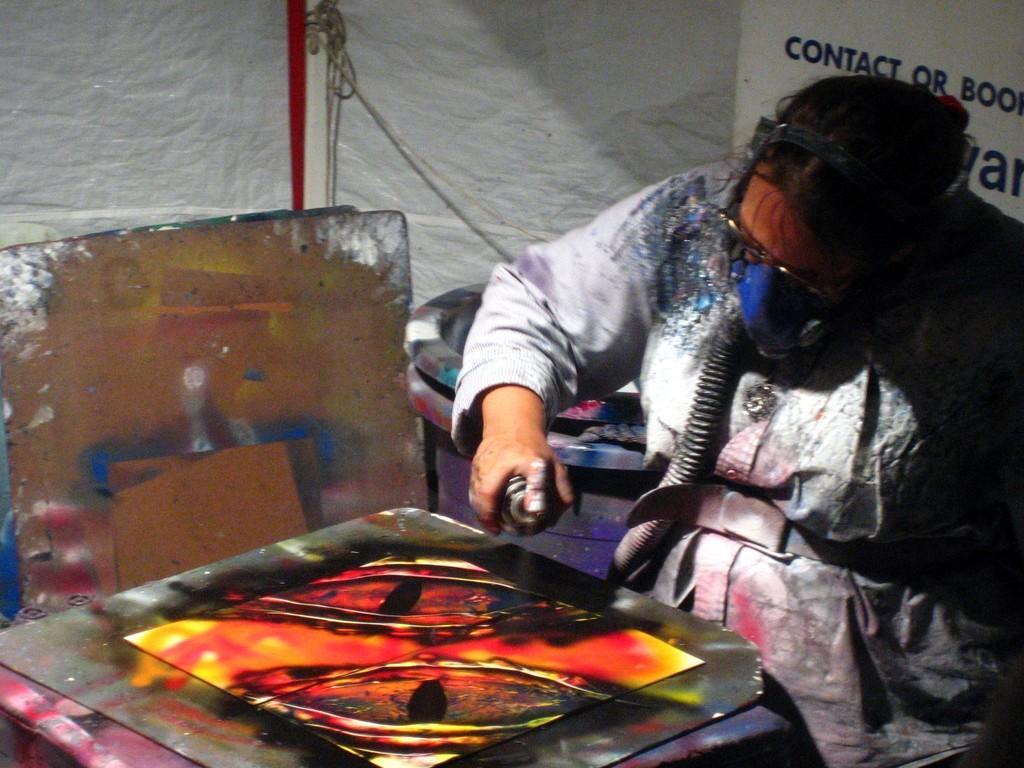Please provide a concise description of this image. In this picture we can observe a person wearing a mask to his nose and mouth. The person is spraying on the plate. We can observe an orange and black color paint on the metal plate. In the background we can observe a white color cloth. 